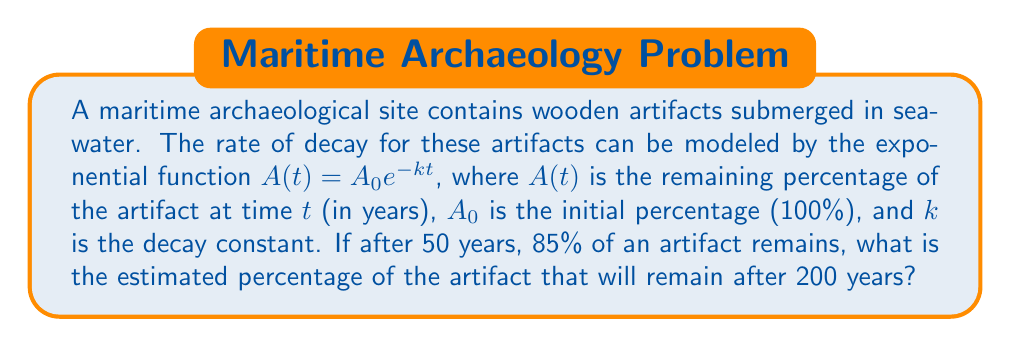Solve this math problem. 1) We start with the exponential decay function:
   $A(t) = A_0e^{-kt}$

2) We know that $A_0 = 100\%$ (initial state) and after 50 years, 85% remains. Let's use this to find $k$:
   $85 = 100e^{-k(50)}$

3) Divide both sides by 100:
   $0.85 = e^{-50k}$

4) Take the natural log of both sides:
   $\ln(0.85) = -50k$

5) Solve for $k$:
   $k = -\frac{\ln(0.85)}{50} \approx 0.00326$

6) Now that we have $k$, we can use the original function to find the percentage remaining after 200 years:
   $A(200) = 100e^{-0.00326(200)}$

7) Calculate:
   $A(200) = 100e^{-0.652} \approx 52.09\%$
Answer: $52.09\%$ 